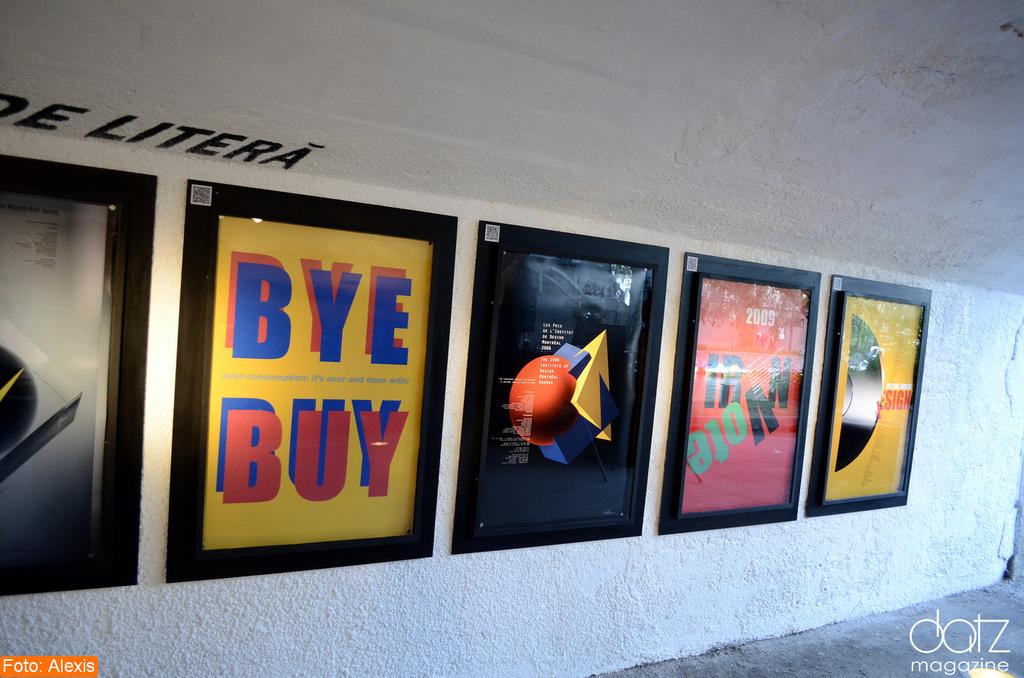What does the yellow ad say?
Offer a terse response. Bye buy. 